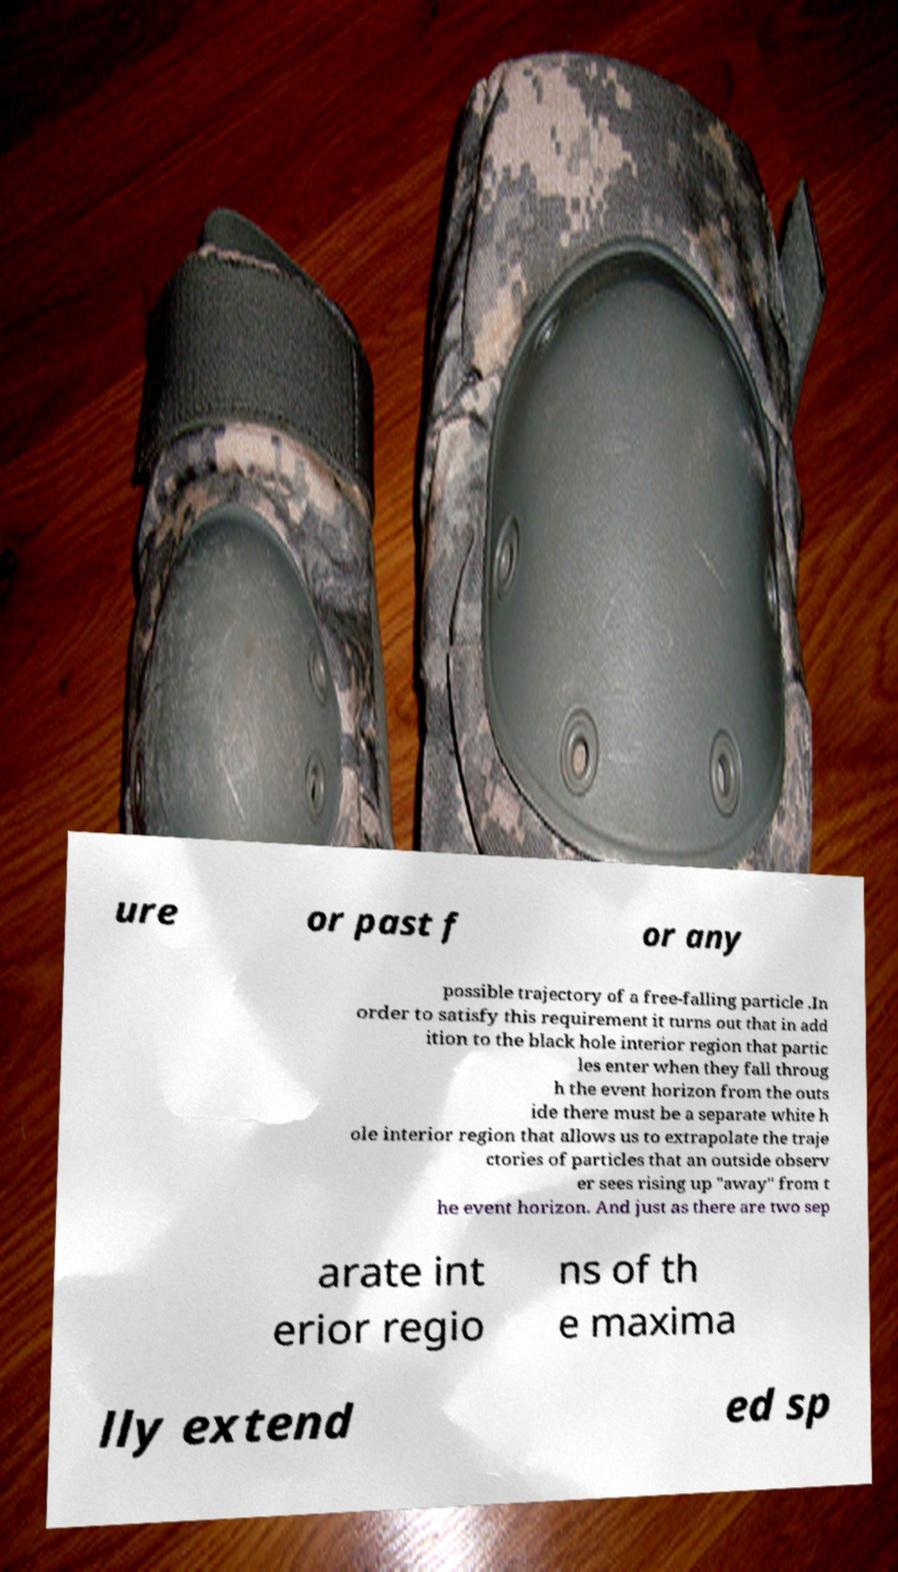Could you extract and type out the text from this image? ure or past f or any possible trajectory of a free-falling particle .In order to satisfy this requirement it turns out that in add ition to the black hole interior region that partic les enter when they fall throug h the event horizon from the outs ide there must be a separate white h ole interior region that allows us to extrapolate the traje ctories of particles that an outside observ er sees rising up "away" from t he event horizon. And just as there are two sep arate int erior regio ns of th e maxima lly extend ed sp 